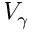Convert formula to latex. <formula><loc_0><loc_0><loc_500><loc_500>V _ { \gamma }</formula> 